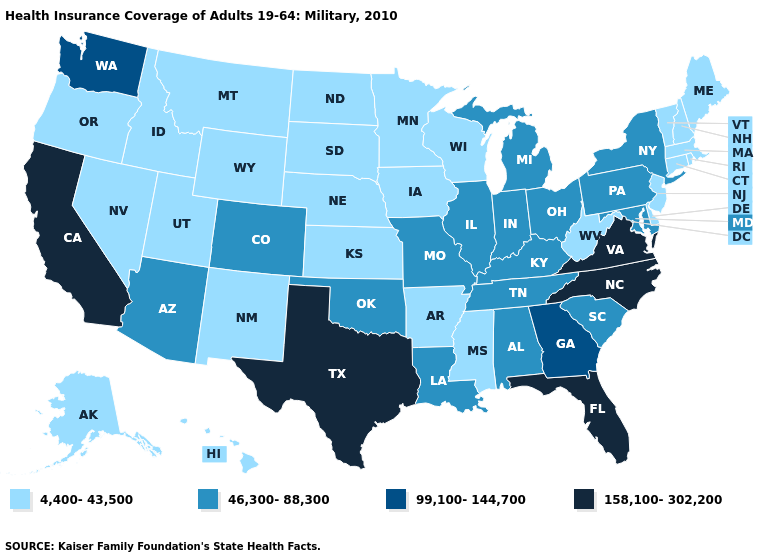Which states have the highest value in the USA?
Concise answer only. California, Florida, North Carolina, Texas, Virginia. What is the value of Michigan?
Keep it brief. 46,300-88,300. Which states hav the highest value in the Northeast?
Keep it brief. New York, Pennsylvania. Does Wyoming have the lowest value in the West?
Keep it brief. Yes. What is the value of North Carolina?
Write a very short answer. 158,100-302,200. Among the states that border North Carolina , which have the lowest value?
Give a very brief answer. South Carolina, Tennessee. Name the states that have a value in the range 158,100-302,200?
Keep it brief. California, Florida, North Carolina, Texas, Virginia. How many symbols are there in the legend?
Short answer required. 4. Among the states that border Michigan , which have the highest value?
Quick response, please. Indiana, Ohio. Does the map have missing data?
Quick response, please. No. What is the highest value in the USA?
Short answer required. 158,100-302,200. Name the states that have a value in the range 158,100-302,200?
Short answer required. California, Florida, North Carolina, Texas, Virginia. What is the value of Florida?
Answer briefly. 158,100-302,200. Name the states that have a value in the range 4,400-43,500?
Give a very brief answer. Alaska, Arkansas, Connecticut, Delaware, Hawaii, Idaho, Iowa, Kansas, Maine, Massachusetts, Minnesota, Mississippi, Montana, Nebraska, Nevada, New Hampshire, New Jersey, New Mexico, North Dakota, Oregon, Rhode Island, South Dakota, Utah, Vermont, West Virginia, Wisconsin, Wyoming. 